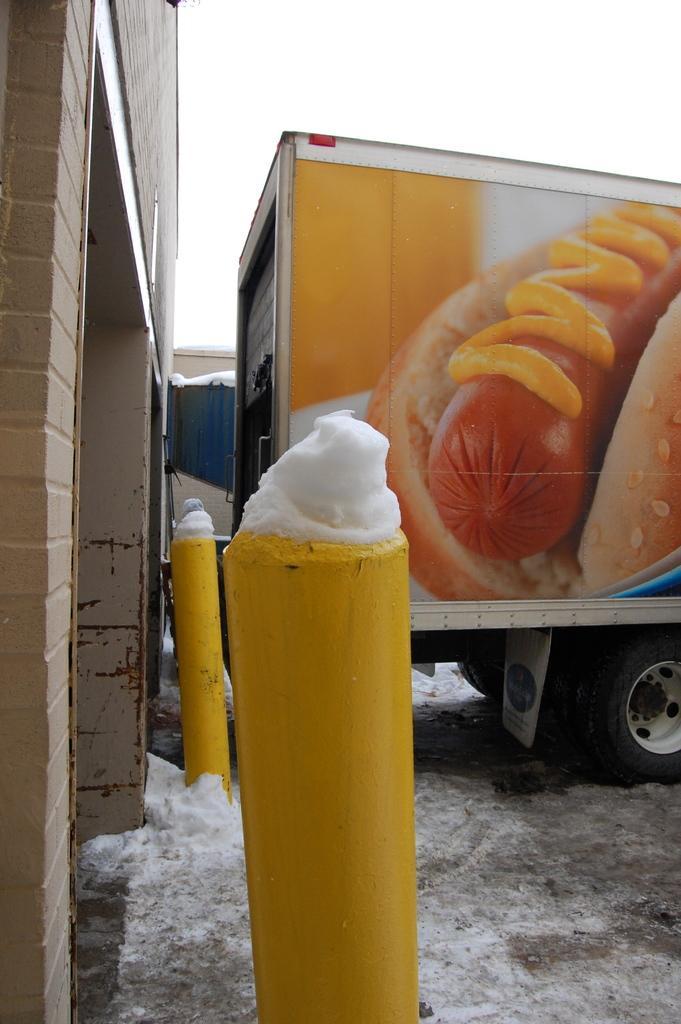Could you give a brief overview of what you see in this image? This image is taken outdoors. At the bottom of the image there is a ground covered with snow. On the right side of the image a truck is parked on the ground. On the left side of the image there is a wall and there are two poles. 